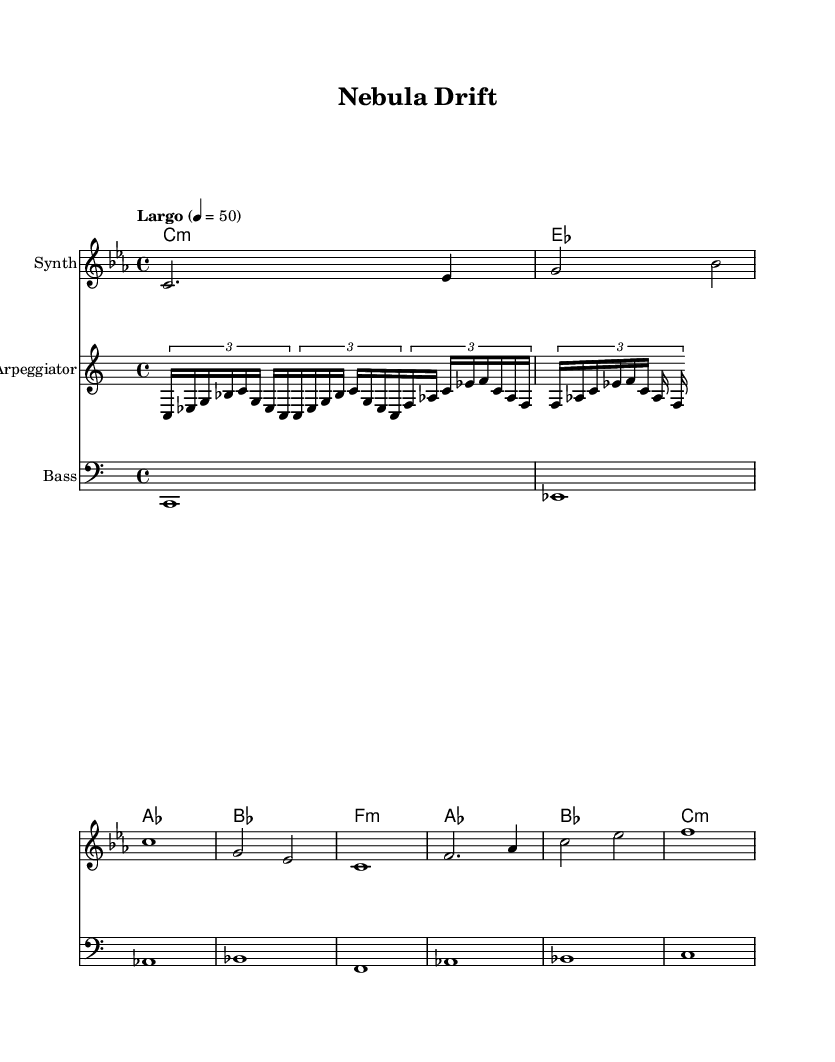What is the key signature of this music? The key signature is C minor, which has three flats: B flat, E flat, and A flat. This is indicated in the global settings of the sheet music.
Answer: C minor What is the time signature of this piece? The time signature is 4/4, which means there are four beats in a measure and the quarter note gets one beat. This is stated in the global settings.
Answer: 4/4 What is the tempo marking indicated on the sheet music? The tempo marking is "Largo," which typically indicates a slow tempo. The specific metronome marking given is a quarter note equals 50 beats per minute.
Answer: Largo Which instruments are featured in this composition? The composition features three instruments: a Synth for melody, an Arpeggiator for arpeggios, and a Bass for the bass line. This is mentioned in the instrument names in each staff.
Answer: Synth, Arpeggiator, Bass What type of chord appears at the beginning of the harmony? The first chord is a C minor chord, as indicated by the "c1:m" in the harmony line. This tells us which chord is played in the first measure.
Answer: C minor How many measures are present in the melody section? There are eight measures in the melody section, which can be counted by looking at the measure bars indicated in the melody line.
Answer: 8 What is the rhythmic structure of the arpeggiator in the first measure? The arpeggiator uses a tuplet 3/2 in the first measure, which means that three notes are played in the time of two, creating a triplet feel. This is described in the arpeggiator line.
Answer: Triplet 